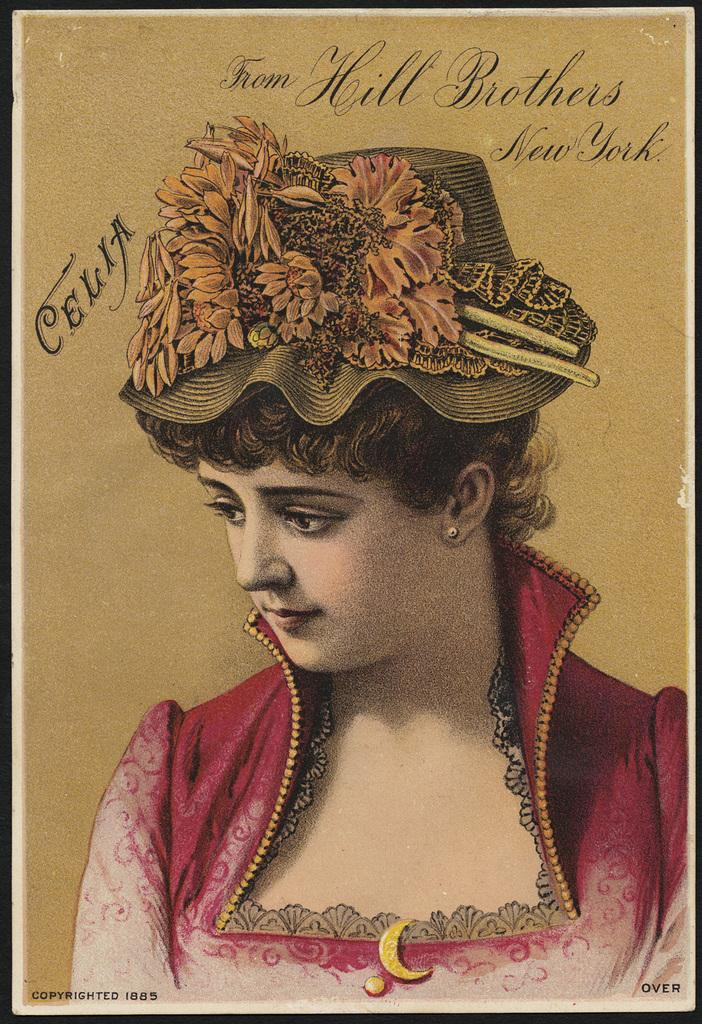What is depicted in the image? There is a painting of a woman in the image. Can you describe the subject of the painting? The painting features a woman as its subject. What is the woman arguing about in the painting? There is no indication of an argument in the painting, as it only depicts a woman. What color is the chess piece the woman is holding in the painting? There is no chess piece or any reference to a chess game in the painting; it only features a woman. 